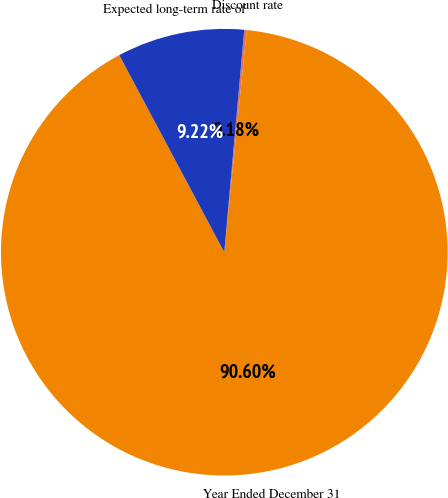Convert chart. <chart><loc_0><loc_0><loc_500><loc_500><pie_chart><fcel>Year Ended December 31<fcel>Discount rate<fcel>Expected long-term rate of<nl><fcel>90.6%<fcel>0.18%<fcel>9.22%<nl></chart> 